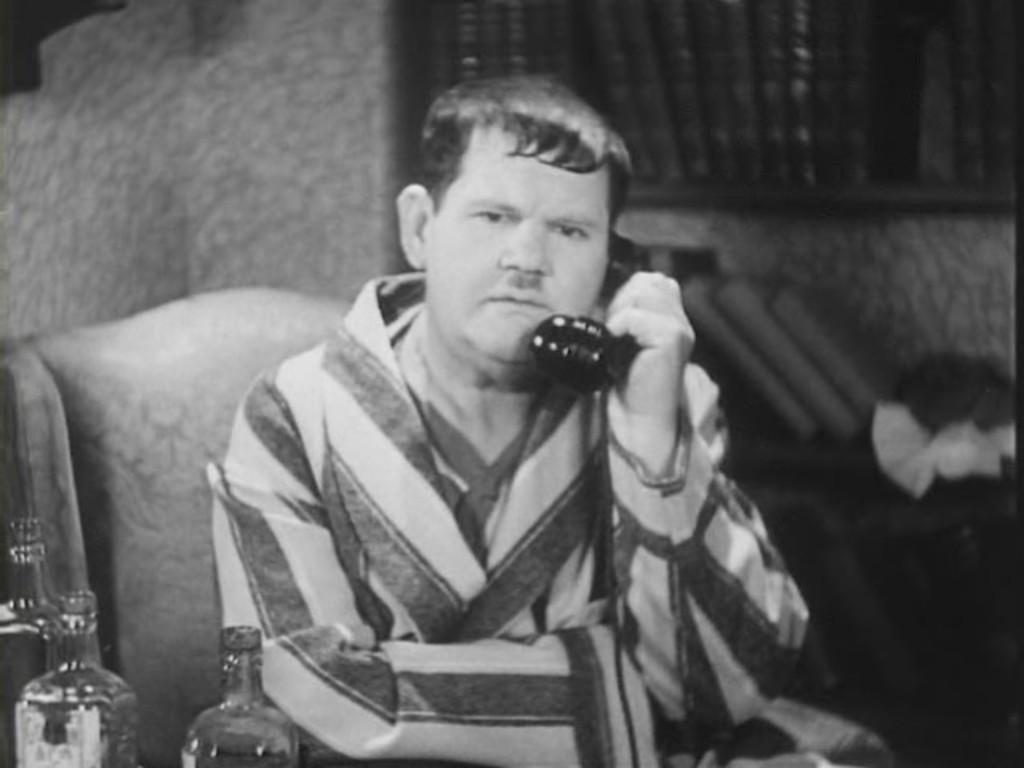What is the person in the image doing? The person is sitting on a chair and holding a telephone. What objects can be seen near the person? There are bottles visible in the image. What can be seen in the background of the image? There is a wall and a window in the background. What type of range can be seen in the image? There is no range present in the image. Is the person playing volleyball in the image? No, the person is sitting on a chair and holding a telephone, not playing volleyball. 